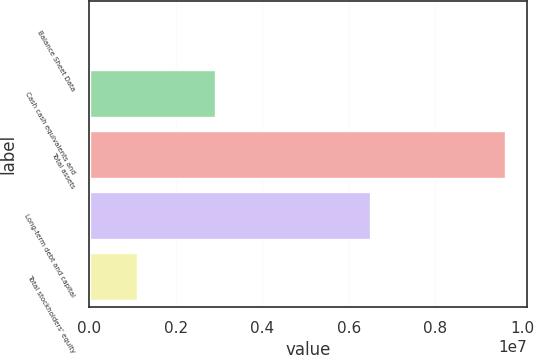<chart> <loc_0><loc_0><loc_500><loc_500><bar_chart><fcel>Balance Sheet Data<fcel>Cash cash equivalents and<fcel>Total assets<fcel>Long-term debt and capital<fcel>Total stockholders' equity<nl><fcel>2010<fcel>2.94038e+06<fcel>9.63215e+06<fcel>6.51494e+06<fcel>1.13344e+06<nl></chart> 